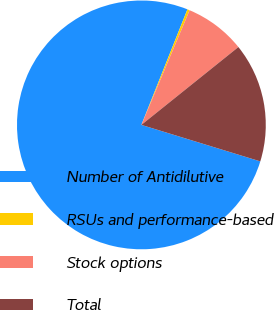Convert chart. <chart><loc_0><loc_0><loc_500><loc_500><pie_chart><fcel>Number of Antidilutive<fcel>RSUs and performance-based<fcel>Stock options<fcel>Total<nl><fcel>76.29%<fcel>0.3%<fcel>7.9%<fcel>15.5%<nl></chart> 